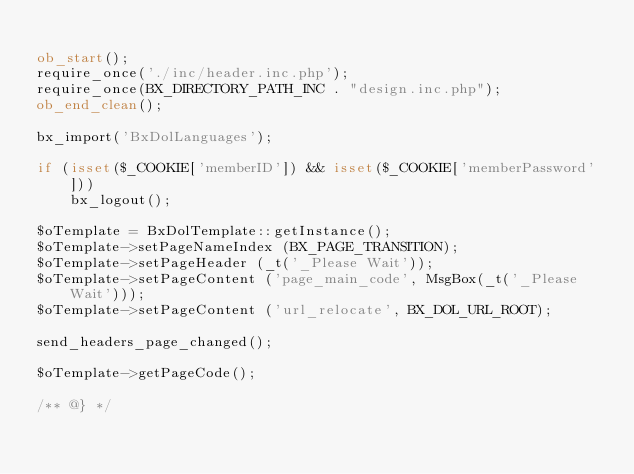<code> <loc_0><loc_0><loc_500><loc_500><_PHP_>
ob_start();
require_once('./inc/header.inc.php');
require_once(BX_DIRECTORY_PATH_INC . "design.inc.php");
ob_end_clean();

bx_import('BxDolLanguages');

if (isset($_COOKIE['memberID']) && isset($_COOKIE['memberPassword']))
    bx_logout();

$oTemplate = BxDolTemplate::getInstance();
$oTemplate->setPageNameIndex (BX_PAGE_TRANSITION);
$oTemplate->setPageHeader (_t('_Please Wait'));
$oTemplate->setPageContent ('page_main_code', MsgBox(_t('_Please Wait')));
$oTemplate->setPageContent ('url_relocate', BX_DOL_URL_ROOT);

send_headers_page_changed();

$oTemplate->getPageCode();

/** @} */
</code> 